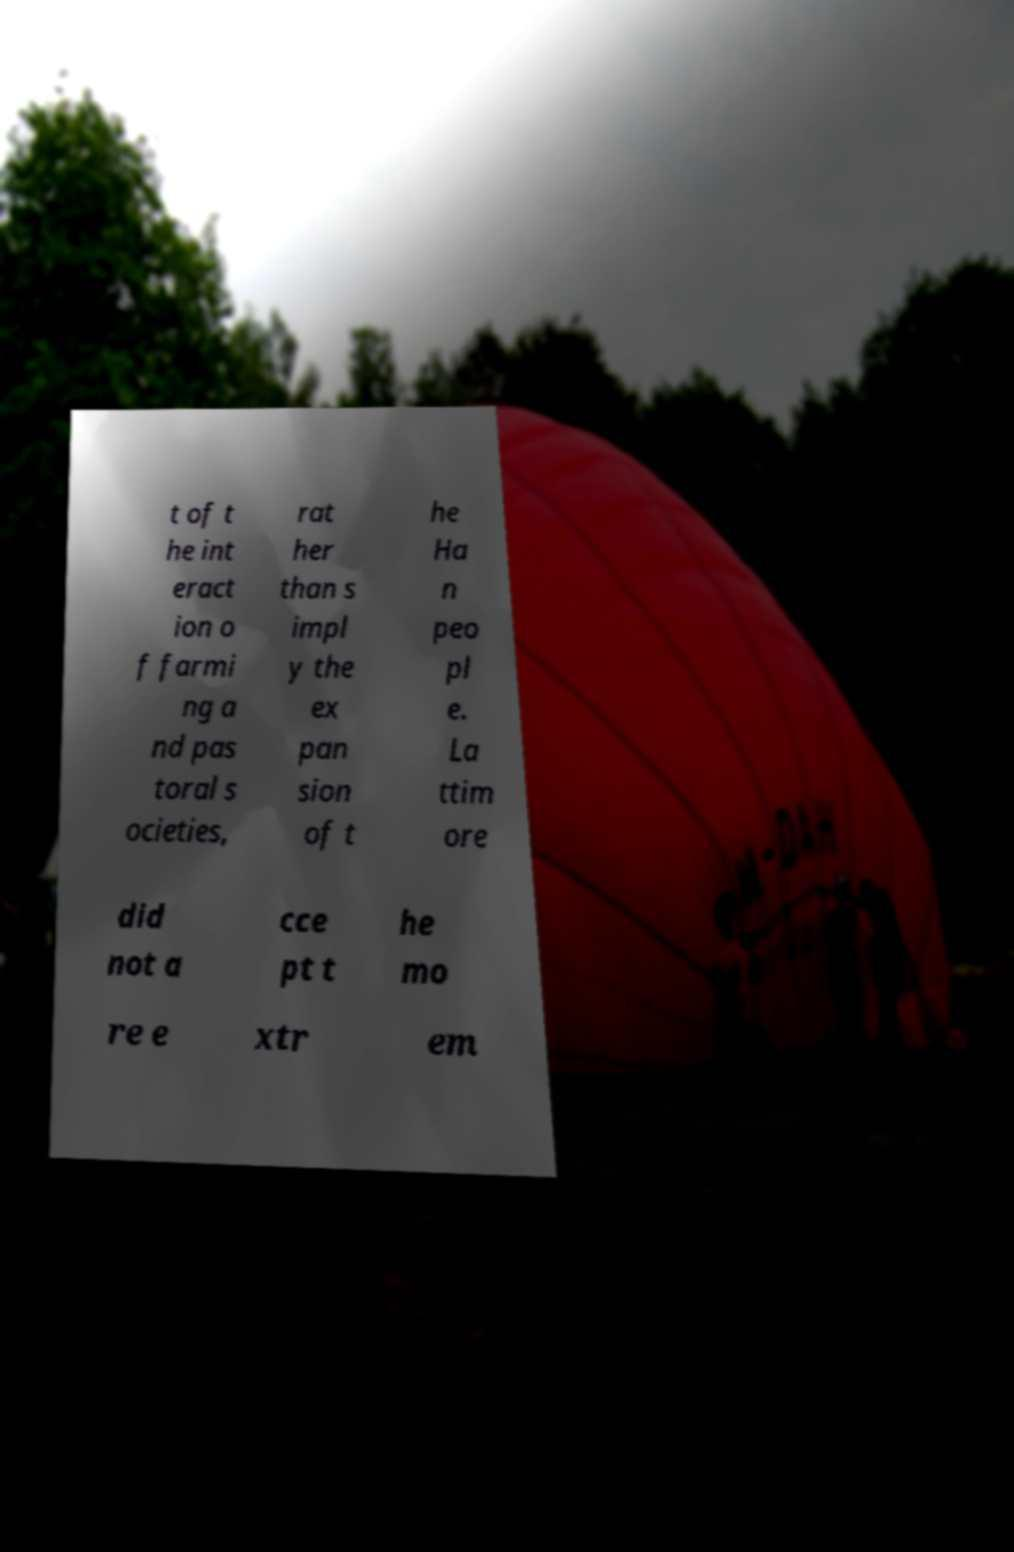Can you accurately transcribe the text from the provided image for me? t of t he int eract ion o f farmi ng a nd pas toral s ocieties, rat her than s impl y the ex pan sion of t he Ha n peo pl e. La ttim ore did not a cce pt t he mo re e xtr em 